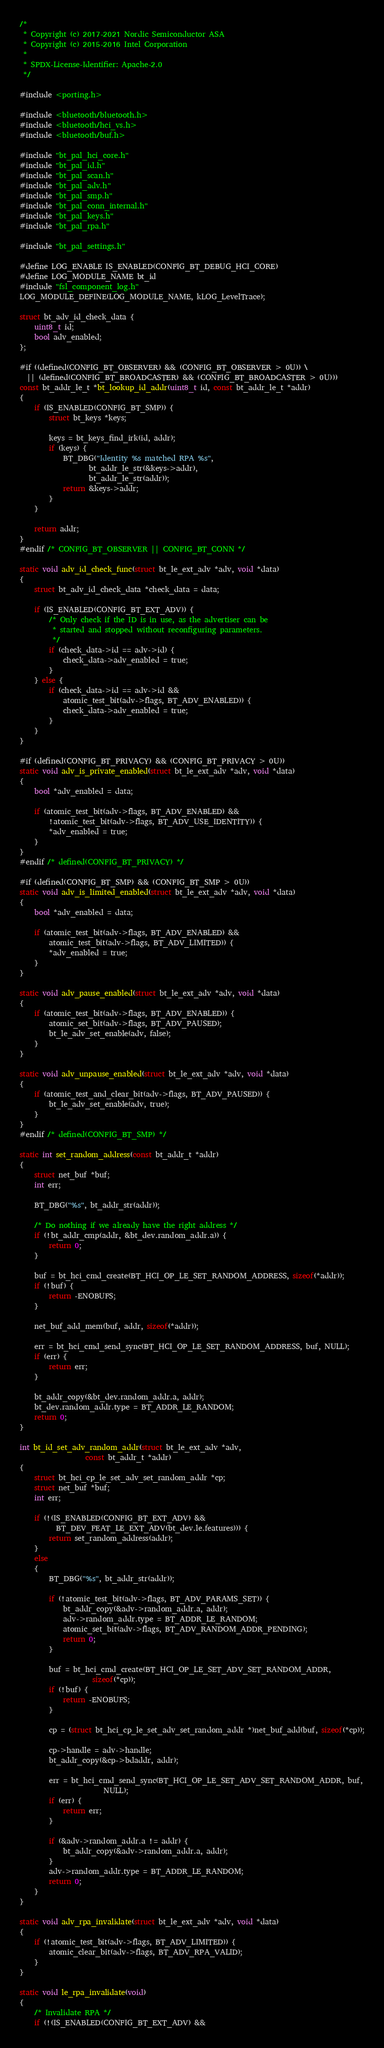Convert code to text. <code><loc_0><loc_0><loc_500><loc_500><_C_>/*
 * Copyright (c) 2017-2021 Nordic Semiconductor ASA
 * Copyright (c) 2015-2016 Intel Corporation
 *
 * SPDX-License-Identifier: Apache-2.0
 */

#include <porting.h>

#include <bluetooth/bluetooth.h>
#include <bluetooth/hci_vs.h>
#include <bluetooth/buf.h>

#include "bt_pal_hci_core.h"
#include "bt_pal_id.h"
#include "bt_pal_scan.h"
#include "bt_pal_adv.h"
#include "bt_pal_smp.h"
#include "bt_pal_conn_internal.h"
#include "bt_pal_keys.h"
#include "bt_pal_rpa.h"

#include "bt_pal_settings.h"

#define LOG_ENABLE IS_ENABLED(CONFIG_BT_DEBUG_HCI_CORE)
#define LOG_MODULE_NAME bt_id
#include "fsl_component_log.h"
LOG_MODULE_DEFINE(LOG_MODULE_NAME, kLOG_LevelTrace);

struct bt_adv_id_check_data {
	uint8_t id;
	bool adv_enabled;
};

#if ((defined(CONFIG_BT_OBSERVER) && (CONFIG_BT_OBSERVER > 0U)) \
  || (defined(CONFIG_BT_BROADCASTER) && (CONFIG_BT_BROADCASTER > 0U)))
const bt_addr_le_t *bt_lookup_id_addr(uint8_t id, const bt_addr_le_t *addr)
{
	if (IS_ENABLED(CONFIG_BT_SMP)) {
		struct bt_keys *keys;

		keys = bt_keys_find_irk(id, addr);
		if (keys) {
			BT_DBG("Identity %s matched RPA %s",
			       bt_addr_le_str(&keys->addr),
			       bt_addr_le_str(addr));
			return &keys->addr;
		}
	}

	return addr;
}
#endif /* CONFIG_BT_OBSERVER || CONFIG_BT_CONN */

static void adv_id_check_func(struct bt_le_ext_adv *adv, void *data)
{
	struct bt_adv_id_check_data *check_data = data;

	if (IS_ENABLED(CONFIG_BT_EXT_ADV)) {
		/* Only check if the ID is in use, as the advertiser can be
		 * started and stopped without reconfiguring parameters.
		 */
		if (check_data->id == adv->id) {
			check_data->adv_enabled = true;
		}
	} else {
		if (check_data->id == adv->id &&
		    atomic_test_bit(adv->flags, BT_ADV_ENABLED)) {
			check_data->adv_enabled = true;
		}
	}
}

#if (defined(CONFIG_BT_PRIVACY) && (CONFIG_BT_PRIVACY > 0U))
static void adv_is_private_enabled(struct bt_le_ext_adv *adv, void *data)
{
	bool *adv_enabled = data;

	if (atomic_test_bit(adv->flags, BT_ADV_ENABLED) &&
	    !atomic_test_bit(adv->flags, BT_ADV_USE_IDENTITY)) {
		*adv_enabled = true;
	}
}
#endif /* defined(CONFIG_BT_PRIVACY) */

#if (defined(CONFIG_BT_SMP) && (CONFIG_BT_SMP > 0U))
static void adv_is_limited_enabled(struct bt_le_ext_adv *adv, void *data)
{
	bool *adv_enabled = data;

	if (atomic_test_bit(adv->flags, BT_ADV_ENABLED) &&
	    atomic_test_bit(adv->flags, BT_ADV_LIMITED)) {
		*adv_enabled = true;
	}
}

static void adv_pause_enabled(struct bt_le_ext_adv *adv, void *data)
{
	if (atomic_test_bit(adv->flags, BT_ADV_ENABLED)) {
		atomic_set_bit(adv->flags, BT_ADV_PAUSED);
		bt_le_adv_set_enable(adv, false);
	}
}

static void adv_unpause_enabled(struct bt_le_ext_adv *adv, void *data)
{
	if (atomic_test_and_clear_bit(adv->flags, BT_ADV_PAUSED)) {
		bt_le_adv_set_enable(adv, true);
	}
}
#endif /* defined(CONFIG_BT_SMP) */

static int set_random_address(const bt_addr_t *addr)
{
	struct net_buf *buf;
	int err;

	BT_DBG("%s", bt_addr_str(addr));

	/* Do nothing if we already have the right address */
	if (!bt_addr_cmp(addr, &bt_dev.random_addr.a)) {
		return 0;
	}

	buf = bt_hci_cmd_create(BT_HCI_OP_LE_SET_RANDOM_ADDRESS, sizeof(*addr));
	if (!buf) {
		return -ENOBUFS;
	}

	net_buf_add_mem(buf, addr, sizeof(*addr));

	err = bt_hci_cmd_send_sync(BT_HCI_OP_LE_SET_RANDOM_ADDRESS, buf, NULL);
	if (err) {
		return err;
	}

	bt_addr_copy(&bt_dev.random_addr.a, addr);
	bt_dev.random_addr.type = BT_ADDR_LE_RANDOM;
	return 0;
}

int bt_id_set_adv_random_addr(struct bt_le_ext_adv *adv,
			      const bt_addr_t *addr)
{
	struct bt_hci_cp_le_set_adv_set_random_addr *cp;
	struct net_buf *buf;
	int err;

	if (!(IS_ENABLED(CONFIG_BT_EXT_ADV) &&
	      BT_DEV_FEAT_LE_EXT_ADV(bt_dev.le.features))) {
		return set_random_address(addr);
	}
	else
	{
		BT_DBG("%s", bt_addr_str(addr));

		if (!atomic_test_bit(adv->flags, BT_ADV_PARAMS_SET)) {
			bt_addr_copy(&adv->random_addr.a, addr);
			adv->random_addr.type = BT_ADDR_LE_RANDOM;
			atomic_set_bit(adv->flags, BT_ADV_RANDOM_ADDR_PENDING);
			return 0;
		}

		buf = bt_hci_cmd_create(BT_HCI_OP_LE_SET_ADV_SET_RANDOM_ADDR,
					sizeof(*cp));
		if (!buf) {
			return -ENOBUFS;
		}

		cp = (struct bt_hci_cp_le_set_adv_set_random_addr *)net_buf_add(buf, sizeof(*cp));

		cp->handle = adv->handle;
		bt_addr_copy(&cp->bdaddr, addr);

		err = bt_hci_cmd_send_sync(BT_HCI_OP_LE_SET_ADV_SET_RANDOM_ADDR, buf,
					   NULL);
		if (err) {
			return err;
		}

		if (&adv->random_addr.a != addr) {
			bt_addr_copy(&adv->random_addr.a, addr);
		}
		adv->random_addr.type = BT_ADDR_LE_RANDOM;
		return 0;
	}
}

static void adv_rpa_invalidate(struct bt_le_ext_adv *adv, void *data)
{
	if (!atomic_test_bit(adv->flags, BT_ADV_LIMITED)) {
		atomic_clear_bit(adv->flags, BT_ADV_RPA_VALID);
	}
}

static void le_rpa_invalidate(void)
{
	/* Invalidate RPA */
	if (!(IS_ENABLED(CONFIG_BT_EXT_ADV) &&</code> 